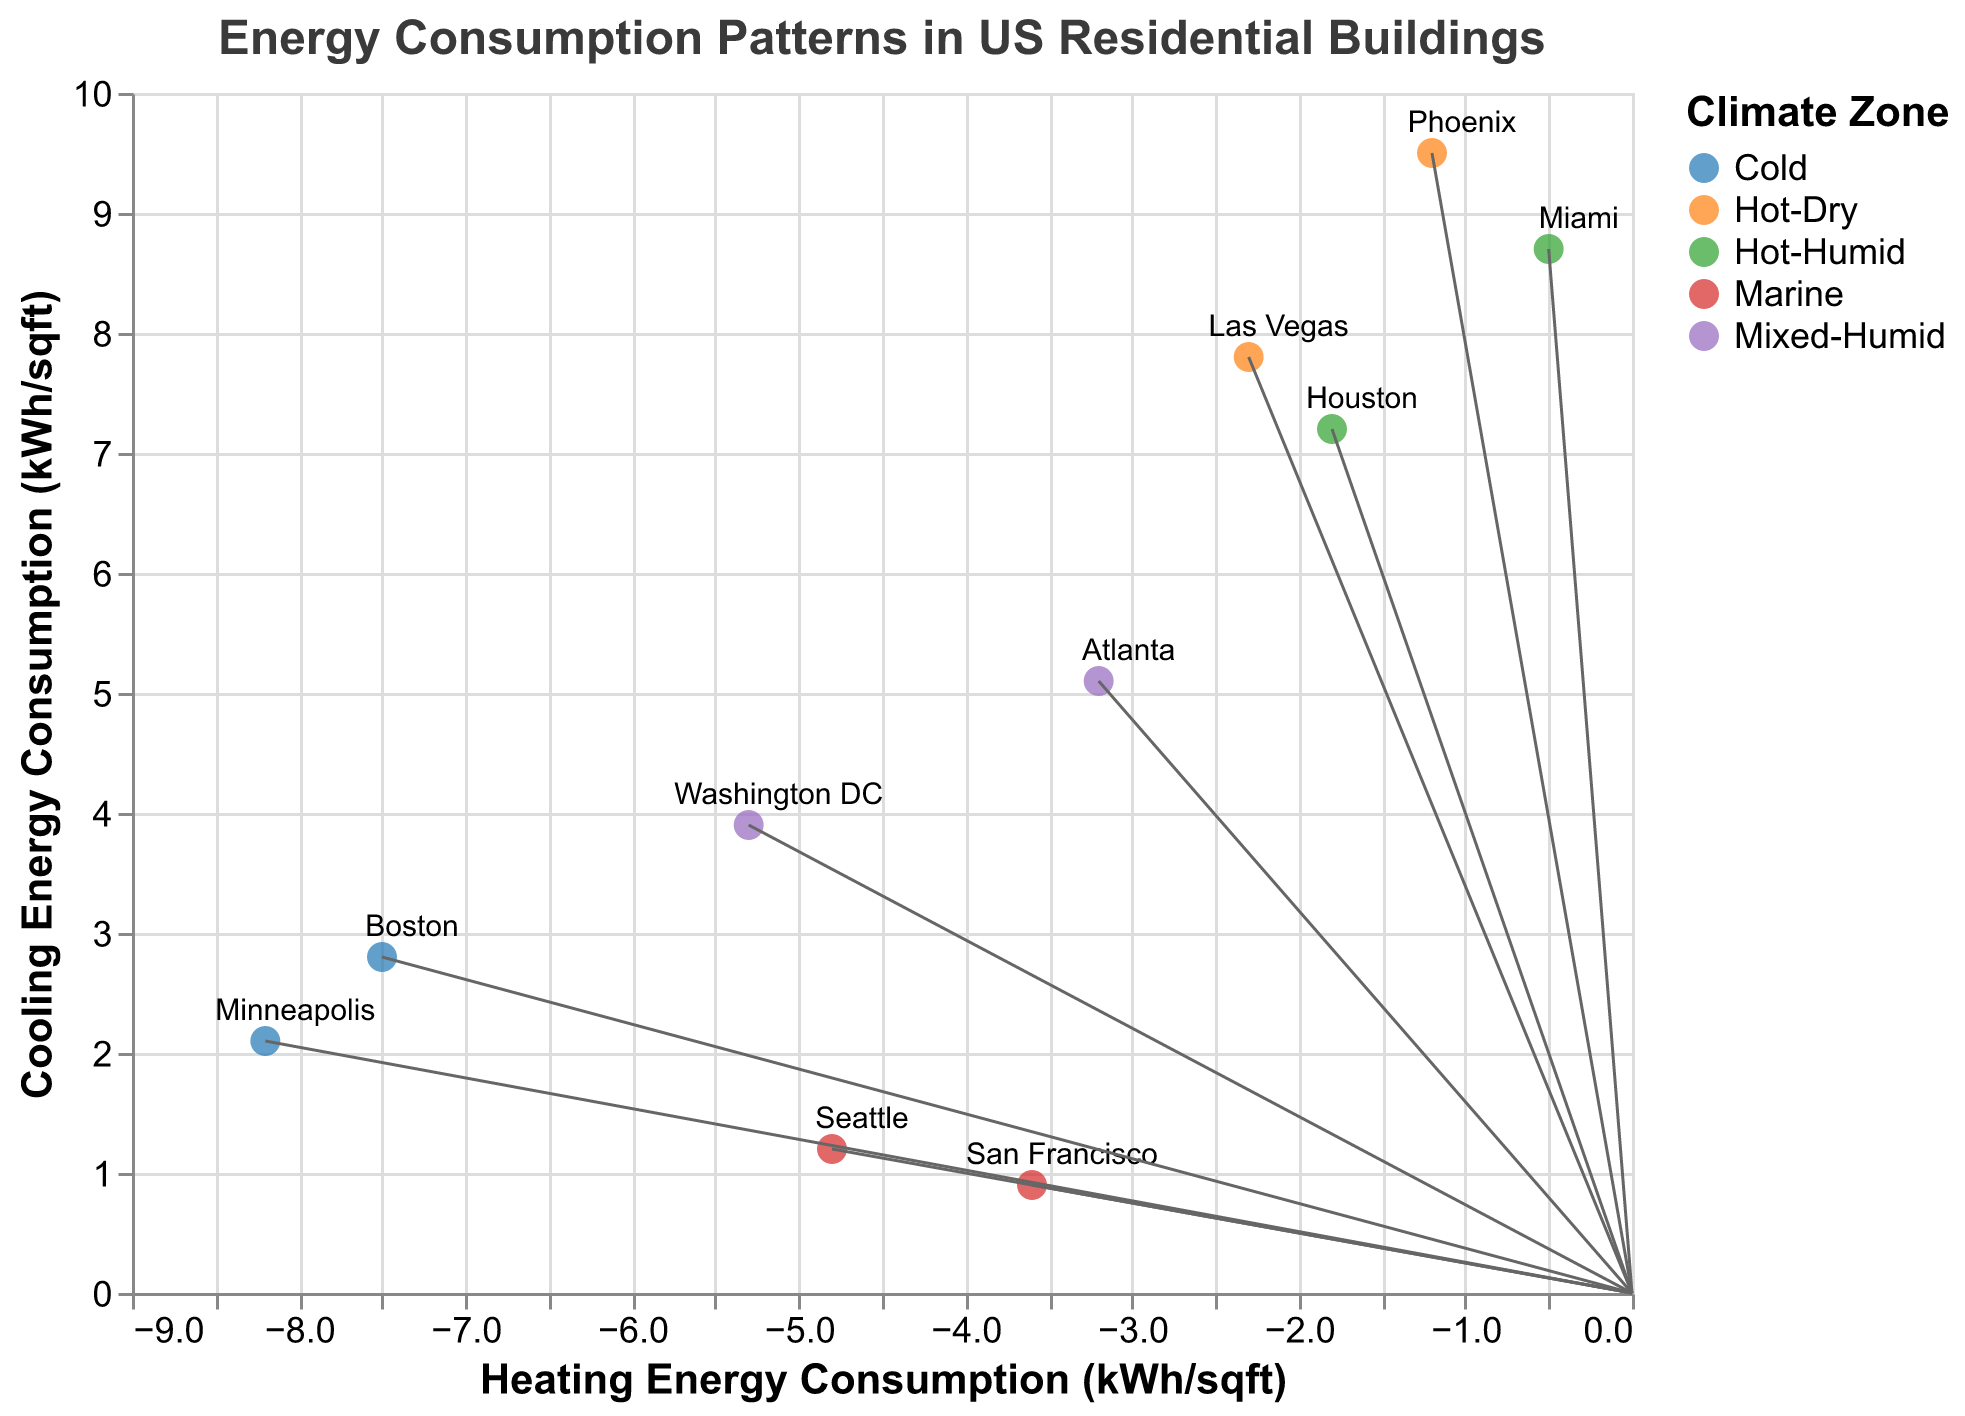What is the title of the plot? The title is usually located at the top center of the plot and is typically displayed in a larger font. Here, it reads "Energy Consumption Patterns in US Residential Buildings."
Answer: Energy Consumption Patterns in US Residential Buildings How many climate zones are represented in the figure? By looking at the color legend that distinguishes different climate zones, we can count the number of unique climate zones. The given data represents five climate zones: Cold, Mixed-Humid, Hot-Humid, Hot-Dry, and Marine.
Answer: 5 Which city has the highest cooling energy consumption? By locating the city with the highest y-axis value (Cooling Energy Consumption) in the scatter plot, we see that Phoenix has the highest cooling energy consumption.
Answer: Phoenix What is the difference in magnitude between Minneapolis and Miami? The magnitude values for Minneapolis and Miami are 8.5 and 8.7, respectively. The difference is calculated as 8.7 - 8.5.
Answer: 0.2 Which city has the least heating energy consumption? The lowest heating energy consumption corresponds to the most negative x-axis value (Heating Energy Consumption). According to the plot, Miami has the least heating energy consumption.
Answer: Miami What direction is represented by the city of Houston? The direction is displayed in the tooltip or can be inferred from the data table. For Houston, the direction is SW (Southwest).
Answer: SW Compare the heating and cooling energy consumption of cities in the Marine climate zone. For the Marine climate zone, the cities are Seattle and San Francisco. Seattle has heating: -4.8 kWh/sqft and cooling: 1.2 kWh/sqft, whereas San Francisco has heating: -3.6 kWh/sqft and cooling: 0.9 kWh/sqft. Comparing these values: Seattle has higher heating energy consumption, and lower cooling energy consumption compared to San Francisco.
Answer: Seattle has higher heating and lower cooling than San Francisco Which climate zone has the broadest range of magnitude values? By examining the magnitude values for cities within each climate zone, we determine the range as follows: Cold (8.5, 8.0), Mixed-Humid (6.6, 6.0), Hot-Humid (8.7, 7.4), Hot-Dry (9.6, 8.1), Marine (4.9, 3.7). The Hot-Dry climate zone has the widest range, from 8.1 to 9.6.
Answer: Hot-Dry What is the average cooling energy consumption for the Mixed-Humid climate zone? The Mixed-Humid climate zone includes Washington DC (3.9) and Atlanta (5.1). The average is calculated as (3.9 + 5.1) / 2.
Answer: 4.5 